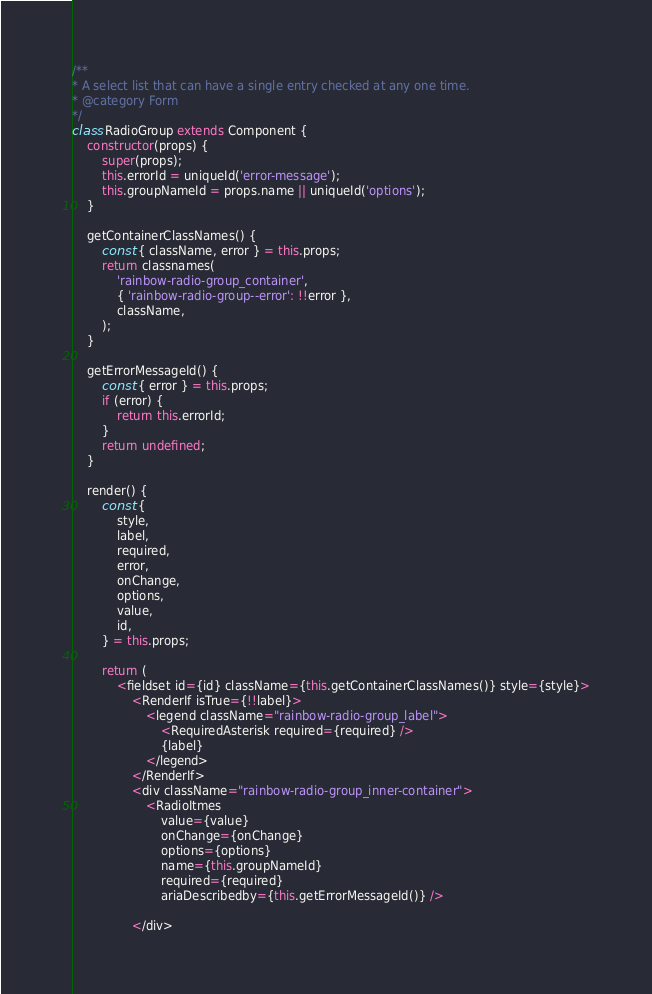Convert code to text. <code><loc_0><loc_0><loc_500><loc_500><_JavaScript_>
/**
* A select list that can have a single entry checked at any one time.
* @category Form
*/
class RadioGroup extends Component {
    constructor(props) {
        super(props);
        this.errorId = uniqueId('error-message');
        this.groupNameId = props.name || uniqueId('options');
    }

    getContainerClassNames() {
        const { className, error } = this.props;
        return classnames(
            'rainbow-radio-group_container',
            { 'rainbow-radio-group--error': !!error },
            className,
        );
    }

    getErrorMessageId() {
        const { error } = this.props;
        if (error) {
            return this.errorId;
        }
        return undefined;
    }

    render() {
        const {
            style,
            label,
            required,
            error,
            onChange,
            options,
            value,
            id,
        } = this.props;

        return (
            <fieldset id={id} className={this.getContainerClassNames()} style={style}>
                <RenderIf isTrue={!!label}>
                    <legend className="rainbow-radio-group_label">
                        <RequiredAsterisk required={required} />
                        {label}
                    </legend>
                </RenderIf>
                <div className="rainbow-radio-group_inner-container">
                    <RadioItmes
                        value={value}
                        onChange={onChange}
                        options={options}
                        name={this.groupNameId}
                        required={required}
                        ariaDescribedby={this.getErrorMessageId()} />

                </div></code> 